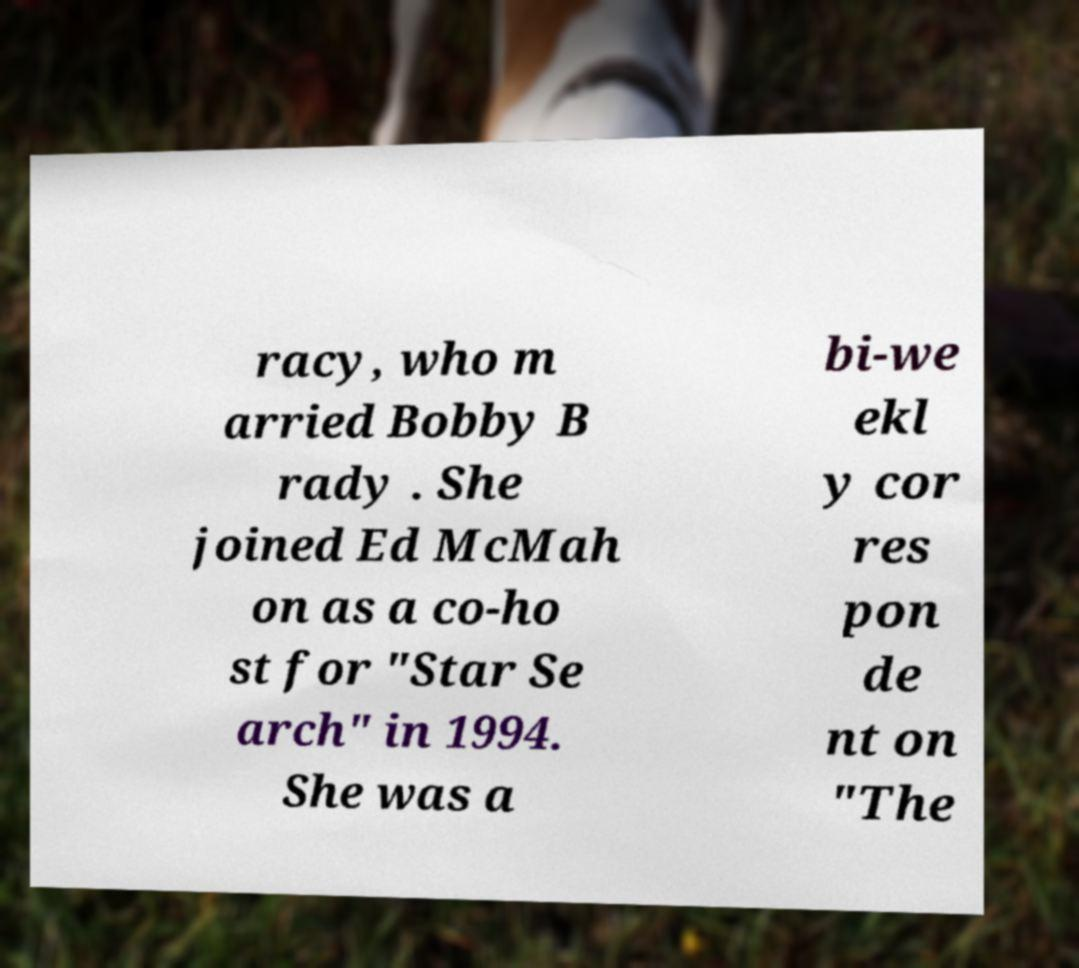Can you accurately transcribe the text from the provided image for me? racy, who m arried Bobby B rady . She joined Ed McMah on as a co-ho st for "Star Se arch" in 1994. She was a bi-we ekl y cor res pon de nt on "The 